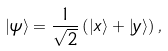Convert formula to latex. <formula><loc_0><loc_0><loc_500><loc_500>\left | \psi \right \rangle = \frac { 1 } { \sqrt { 2 } } \left ( { \left | x \right \rangle + \left | y \right \rangle } \right ) ,</formula> 